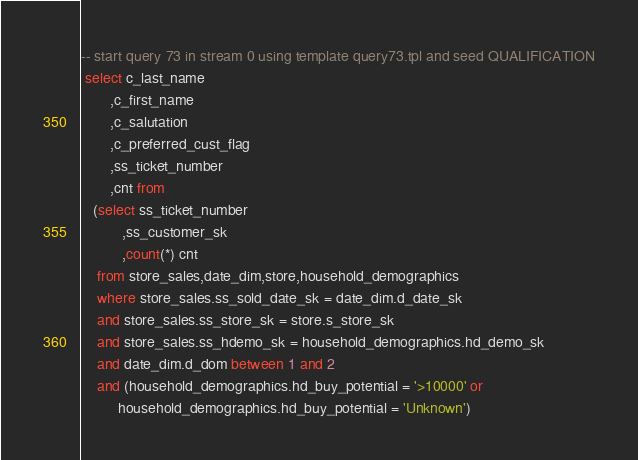<code> <loc_0><loc_0><loc_500><loc_500><_SQL_>-- start query 73 in stream 0 using template query73.tpl and seed QUALIFICATION
 select c_last_name
       ,c_first_name
       ,c_salutation
       ,c_preferred_cust_flag 
       ,ss_ticket_number
       ,cnt from
   (select ss_ticket_number
          ,ss_customer_sk
          ,count(*) cnt
    from store_sales,date_dim,store,household_demographics
    where store_sales.ss_sold_date_sk = date_dim.d_date_sk
    and store_sales.ss_store_sk = store.s_store_sk  
    and store_sales.ss_hdemo_sk = household_demographics.hd_demo_sk
    and date_dim.d_dom between 1 and 2 
    and (household_demographics.hd_buy_potential = '>10000' or
         household_demographics.hd_buy_potential = 'Unknown')</code> 